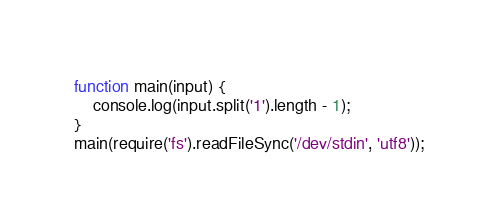<code> <loc_0><loc_0><loc_500><loc_500><_JavaScript_>function main(input) {
    console.log(input.split('1').length - 1);
}
main(require('fs').readFileSync('/dev/stdin', 'utf8'));</code> 